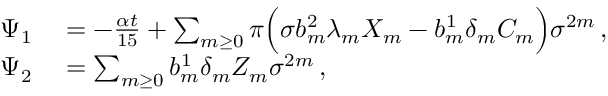<formula> <loc_0><loc_0><loc_500><loc_500>\begin{array} { r l } { \Psi _ { 1 } } & = - \frac { \alpha t } { 1 5 } + \sum _ { m \geq 0 } \pi \left ( \sigma b _ { m } ^ { 2 } \lambda _ { m } X _ { m } - b _ { m } ^ { 1 } \delta _ { m } C _ { m } \right ) \sigma ^ { 2 m } \, , } \\ { \Psi _ { 2 } } & = \sum _ { m \geq 0 } b _ { m } ^ { 1 } \delta _ { m } Z _ { m } \sigma ^ { 2 m } \, , } \end{array}</formula> 